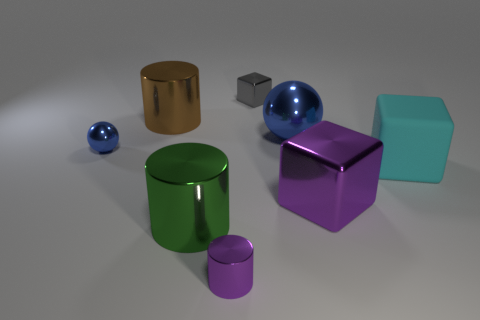How many other things are there of the same color as the tiny shiny sphere?
Offer a terse response. 1. There is a large cyan thing right of the large metal cylinder that is behind the tiny blue shiny ball that is behind the small shiny cylinder; what is it made of?
Your answer should be very brief. Rubber. Are any big gray cylinders visible?
Your answer should be very brief. No. There is a small metal ball; is it the same color as the metallic ball that is to the right of the big green metal thing?
Your answer should be compact. Yes. The big rubber cube has what color?
Your answer should be very brief. Cyan. What color is the tiny object that is the same shape as the large cyan rubber thing?
Give a very brief answer. Gray. Does the small purple thing have the same shape as the brown metallic thing?
Ensure brevity in your answer.  Yes. How many cubes are big red metallic objects or large rubber things?
Offer a terse response. 1. There is a large ball that is made of the same material as the brown object; what is its color?
Your answer should be compact. Blue. There is a gray block that is behind the green thing; is its size the same as the tiny blue object?
Give a very brief answer. Yes. 